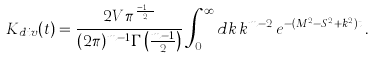Convert formula to latex. <formula><loc_0><loc_0><loc_500><loc_500>K _ { d i v } ( t ) = \frac { 2 V \pi ^ { \frac { m - 1 } { 2 } } } { ( 2 \pi ) ^ { m - 1 } \Gamma \left ( \frac { m - 1 } { 2 } \right ) } \int _ { 0 } ^ { \infty } d k \, k ^ { m - 2 } \, e ^ { - ( M ^ { 2 } - S ^ { 2 } + k ^ { 2 } ) t } \, .</formula> 